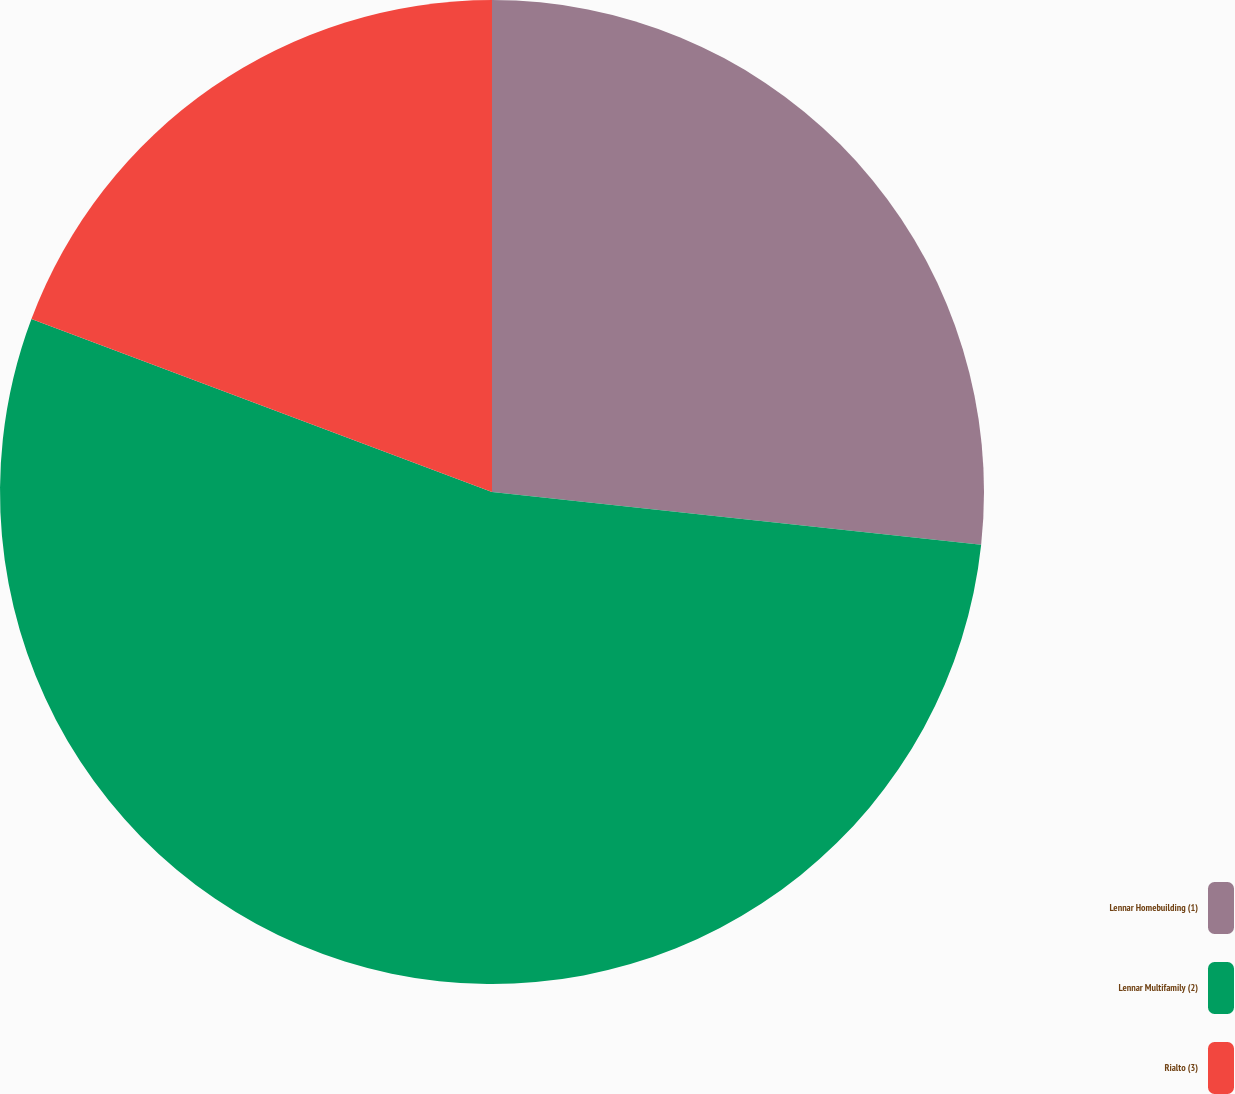Convert chart. <chart><loc_0><loc_0><loc_500><loc_500><pie_chart><fcel>Lennar Homebuilding (1)<fcel>Lennar Multifamily (2)<fcel>Rialto (3)<nl><fcel>26.71%<fcel>54.01%<fcel>19.28%<nl></chart> 